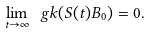<formula> <loc_0><loc_0><loc_500><loc_500>\lim _ { t \to \infty } \ g k ( S ( t ) B _ { 0 } ) = 0 .</formula> 